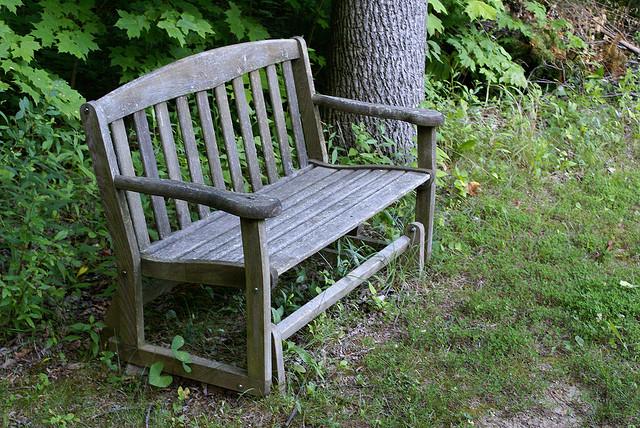Besides wood, what is the bench made of?
Write a very short answer. Nails. How old is this bench?
Short answer required. Old. What color are the leaves on the ground?
Quick response, please. Green. What is the furniture made of?
Short answer required. Wood. Does the bench need staining?
Give a very brief answer. Yes. 